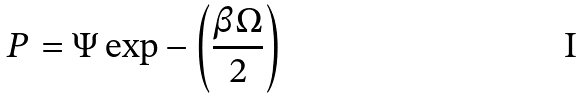Convert formula to latex. <formula><loc_0><loc_0><loc_500><loc_500>P = \Psi \exp - \left ( { \frac { \beta \Omega } { 2 } } \right )</formula> 